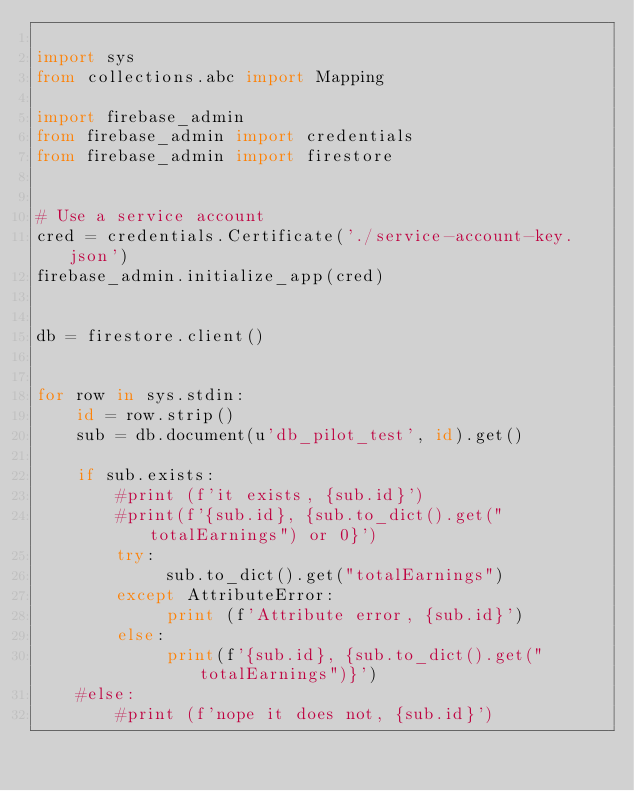Convert code to text. <code><loc_0><loc_0><loc_500><loc_500><_Python_>
import sys
from collections.abc import Mapping

import firebase_admin
from firebase_admin import credentials
from firebase_admin import firestore


# Use a service account
cred = credentials.Certificate('./service-account-key.json')
firebase_admin.initialize_app(cred)


db = firestore.client()


for row in sys.stdin:
    id = row.strip()
    sub = db.document(u'db_pilot_test', id).get()

    if sub.exists:
        #print (f'it exists, {sub.id}')
        #print(f'{sub.id}, {sub.to_dict().get("totalEarnings") or 0}')
        try:
             sub.to_dict().get("totalEarnings")
        except AttributeError:
             print (f'Attribute error, {sub.id}')
        else:
             print(f'{sub.id}, {sub.to_dict().get("totalEarnings")}')
    #else:
        #print (f'nope it does not, {sub.id}')
</code> 